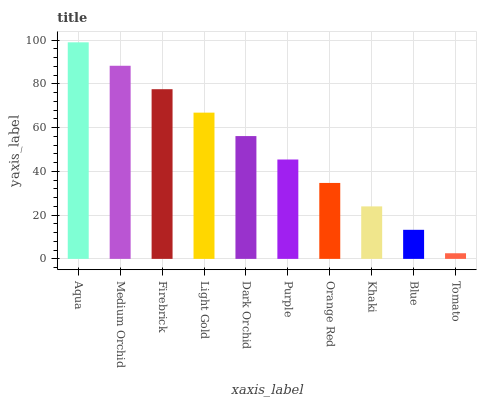Is Tomato the minimum?
Answer yes or no. Yes. Is Aqua the maximum?
Answer yes or no. Yes. Is Medium Orchid the minimum?
Answer yes or no. No. Is Medium Orchid the maximum?
Answer yes or no. No. Is Aqua greater than Medium Orchid?
Answer yes or no. Yes. Is Medium Orchid less than Aqua?
Answer yes or no. Yes. Is Medium Orchid greater than Aqua?
Answer yes or no. No. Is Aqua less than Medium Orchid?
Answer yes or no. No. Is Dark Orchid the high median?
Answer yes or no. Yes. Is Purple the low median?
Answer yes or no. Yes. Is Aqua the high median?
Answer yes or no. No. Is Medium Orchid the low median?
Answer yes or no. No. 